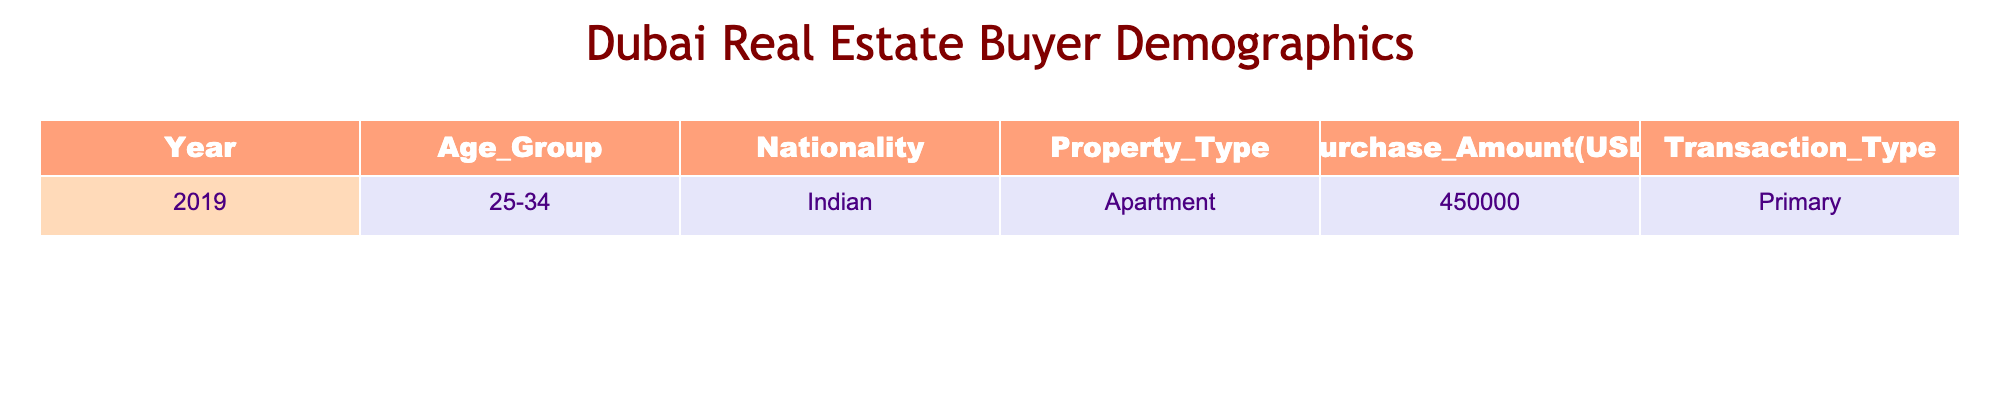What is the most common age group among home buyers in Dubai in 2019? The table shows a single entry for the year 2019, which indicates that the age group of the buyer is 25-34. Thus, without additional data, this is the only age group presented for that year.
Answer: 25-34 How much was the purchase amount for the apartment sold to the Indian buyer in 2019? The table explicitly lists a purchase amount of 450,000 USD for the transaction involving the apartment sold to an Indian buyer in 2019.
Answer: 450000 Did any buyers from the 18-24 age group purchase a property in Dubai in 2019? The data presented shows only one transaction, which is from the age group 25-34. Therefore, no buyers from the 18-24 age group are represented in the table.
Answer: No What type of property was purchased by the Indian buyer in 2019? The table specifies the property type as "Apartment" for the transaction conducted by the Indian buyer in 2019.
Answer: Apartment Calculate the total purchase amount for all entries in 2019. There is only one entry for 2019 with a purchase amount of 450,000 USD. Thus, the total purchase amount is simply 450,000. No addition is necessary since there are no other entries to sum.
Answer: 450000 Was the transaction type for the Indian buyer in 2019 primary or secondary? The table indicates that the transaction type for the Indian buyer in 2019 was "Primary." Hence, it confirms the buyer's first-time property purchase in Dubai.
Answer: Primary If there was another transaction in 2019 with a different nationality, would the nationality of the Indian buyer still be the only one listed in that year? Based on the current data, only one transaction is shown for 2019, which is by an Indian buyer. If there was another transaction with a different nationality, the table would need to reflect that additional data to represent both nationalities. As it stands, only the Indian buyer is listed.
Answer: Yes What is the nationality of the buyer with the transaction recorded for 2019? The data clearly states that the nationality of the buyer for the 2019 transaction was Indian.
Answer: Indian 